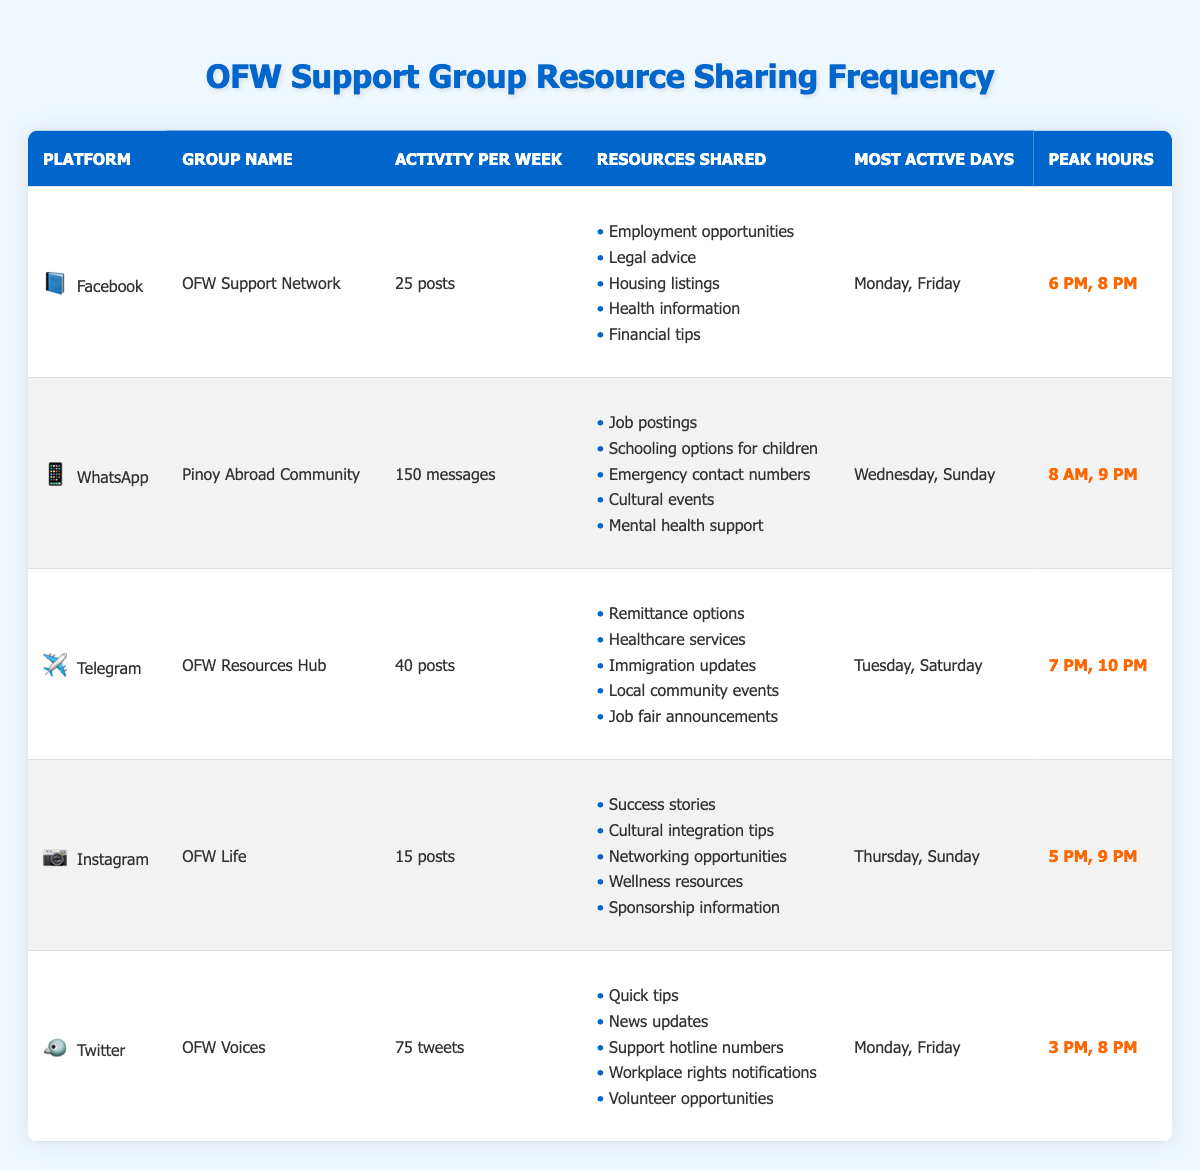What is the average number of posts shared on Facebook each week? The table states that the "average_posts_per_week" for the Facebook group "OFW Support Network" is 25. Therefore, we take this value directly from the table.
Answer: 25 Which group shares the most resources per week? The groups with the highest activity per week are identified as follows: Facebook (25 posts), WhatsApp (150 messages), Telegram (40 posts), Instagram (15 posts), and Twitter (75 tweets). The WhatsApp group "Pinoy Abroad Community" has the highest number with 150 messages.
Answer: Pinoy Abroad Community On which platform do members share cultural integration tips? By reviewing the "resource_types_shared" in the table, the Instagram group "OFW Life" includes "Cultural integration tips" in its resource list.
Answer: Instagram Are Monday and Friday the most active days for only one group? The table indicates that both Facebook ("OFW Support Network") and Twitter ("OFW Voices") have Monday and Friday as their most active days. Since two groups share these days, the answer is false.
Answer: No What is the total number of posts and messages shared per week across all groups? We first sum the weekly activities: Facebook (25) + WhatsApp (150) + Telegram (40) + Instagram (15) + Twitter (75). This gives us 25 + 150 + 40 + 15 + 75 = 305. Therefore, the total number is 305.
Answer: 305 What are the peak hours for the WhatsApp group? The peak hours for the WhatsApp group "Pinoy Abroad Community" are stated as 8 AM and 9 PM. This information can be directly retrieved from the table under the column "Peak Hours".
Answer: 8 AM, 9 PM Is the average number of tweets per week for the Twitter group greater than that for the Facebook group? The table shows Twitter has an average of 75 tweets per week while Facebook has 25 posts per week. Since 75 is greater than 25, the statement is true.
Answer: Yes On which days do Telegram members primarily engage in discussions? The most active days for the Telegram group "OFW Resources Hub" are listed as Tuesday and Saturday. This information is gathered directly from the "Most Active Days" column.
Answer: Tuesday, Saturday Which social media platform has the least amount of activity shared per week? When comparing the average activity: Facebook (25), WhatsApp (150), Telegram (40), Instagram (15), and Twitter (75), Instagram shows the least with 15 posts. Hence, it is the platform with the least amount of activity shared weekly.
Answer: Instagram 